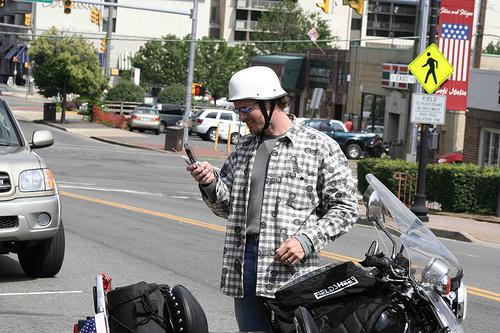Question: what is the person looking at?
Choices:
A. Phone.
B. Watch.
C. Tablet.
D. Television.
Answer with the letter. Answer: A Question: where is the man?
Choices:
A. Police station.
B. Street.
C. Corner.
D. Intersection.
Answer with the letter. Answer: B Question: what was the man riding?
Choices:
A. Tractor.
B. Horse.
C. Bike.
D. Motorcycle.
Answer with the letter. Answer: C Question: what is the yellow sign?
Choices:
A. Caution.
B. Directions.
C. Yield.
D. Crosswalk.
Answer with the letter. Answer: D Question: where is the man located?
Choices:
A. Town.
B. Countryside.
C. Village.
D. City.
Answer with the letter. Answer: D 